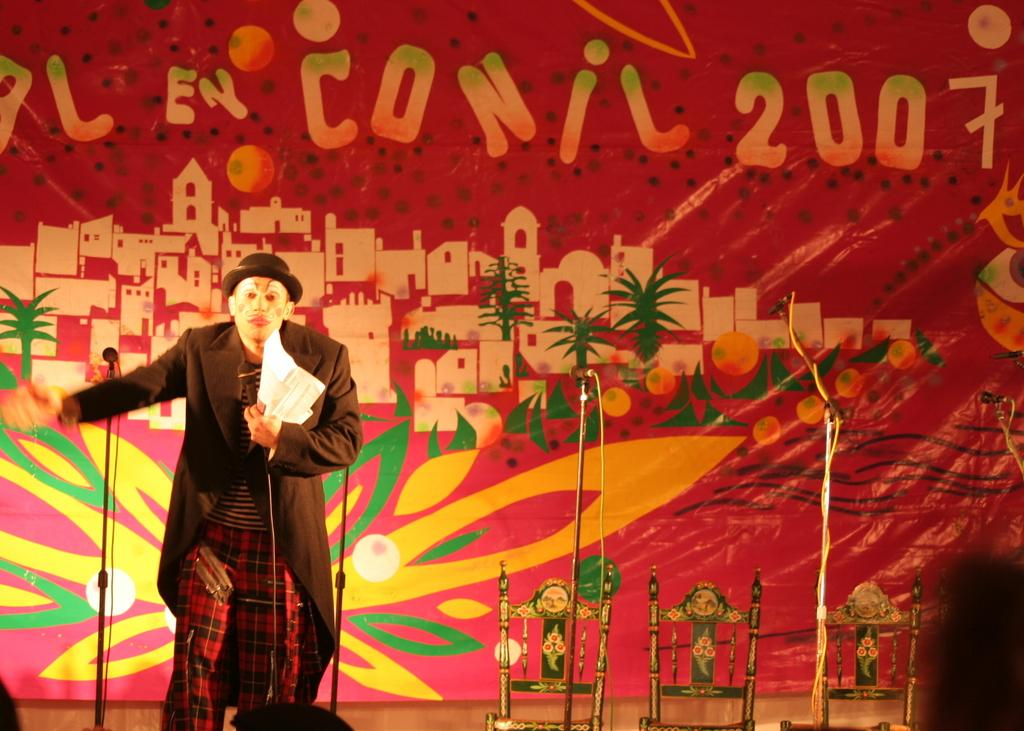What is hanging or displayed in the image? There is a banner in the image. What is the person in the image wearing? The person in the image is wearing a costume. What type of furniture is visible in the image? There are chairs in the image. Can you describe any other objects present in the image? There are other objects present in the image, but their specific details are not mentioned in the provided facts. Can you tell me how fast the beetle is running in the image? There is no beetle present in the image, and therefore no running beetle can be observed. What type of art is displayed on the banner in the image? The provided facts do not mention any specific art on the banner, so we cannot determine its type. 